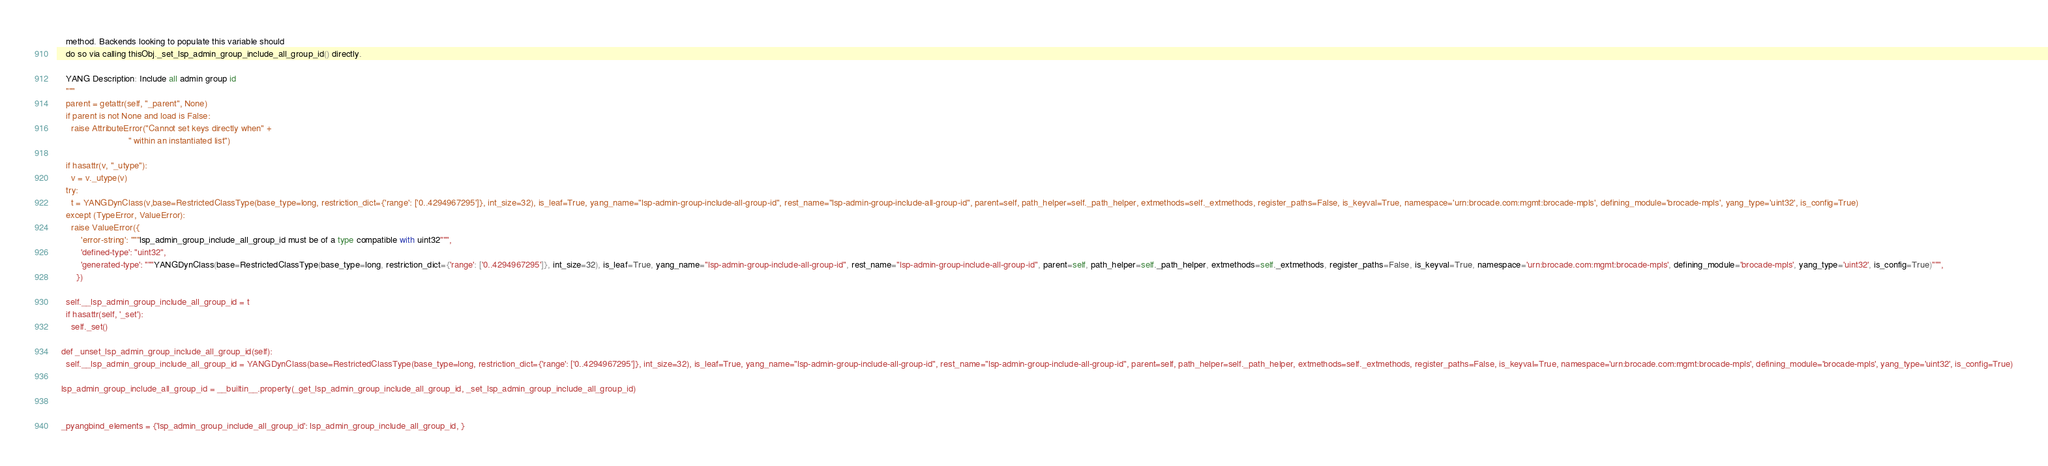<code> <loc_0><loc_0><loc_500><loc_500><_Python_>    method. Backends looking to populate this variable should
    do so via calling thisObj._set_lsp_admin_group_include_all_group_id() directly.

    YANG Description: Include all admin group id
    """
    parent = getattr(self, "_parent", None)
    if parent is not None and load is False:
      raise AttributeError("Cannot set keys directly when" +
                             " within an instantiated list")

    if hasattr(v, "_utype"):
      v = v._utype(v)
    try:
      t = YANGDynClass(v,base=RestrictedClassType(base_type=long, restriction_dict={'range': ['0..4294967295']}, int_size=32), is_leaf=True, yang_name="lsp-admin-group-include-all-group-id", rest_name="lsp-admin-group-include-all-group-id", parent=self, path_helper=self._path_helper, extmethods=self._extmethods, register_paths=False, is_keyval=True, namespace='urn:brocade.com:mgmt:brocade-mpls', defining_module='brocade-mpls', yang_type='uint32', is_config=True)
    except (TypeError, ValueError):
      raise ValueError({
          'error-string': """lsp_admin_group_include_all_group_id must be of a type compatible with uint32""",
          'defined-type': "uint32",
          'generated-type': """YANGDynClass(base=RestrictedClassType(base_type=long, restriction_dict={'range': ['0..4294967295']}, int_size=32), is_leaf=True, yang_name="lsp-admin-group-include-all-group-id", rest_name="lsp-admin-group-include-all-group-id", parent=self, path_helper=self._path_helper, extmethods=self._extmethods, register_paths=False, is_keyval=True, namespace='urn:brocade.com:mgmt:brocade-mpls', defining_module='brocade-mpls', yang_type='uint32', is_config=True)""",
        })

    self.__lsp_admin_group_include_all_group_id = t
    if hasattr(self, '_set'):
      self._set()

  def _unset_lsp_admin_group_include_all_group_id(self):
    self.__lsp_admin_group_include_all_group_id = YANGDynClass(base=RestrictedClassType(base_type=long, restriction_dict={'range': ['0..4294967295']}, int_size=32), is_leaf=True, yang_name="lsp-admin-group-include-all-group-id", rest_name="lsp-admin-group-include-all-group-id", parent=self, path_helper=self._path_helper, extmethods=self._extmethods, register_paths=False, is_keyval=True, namespace='urn:brocade.com:mgmt:brocade-mpls', defining_module='brocade-mpls', yang_type='uint32', is_config=True)

  lsp_admin_group_include_all_group_id = __builtin__.property(_get_lsp_admin_group_include_all_group_id, _set_lsp_admin_group_include_all_group_id)


  _pyangbind_elements = {'lsp_admin_group_include_all_group_id': lsp_admin_group_include_all_group_id, }


</code> 